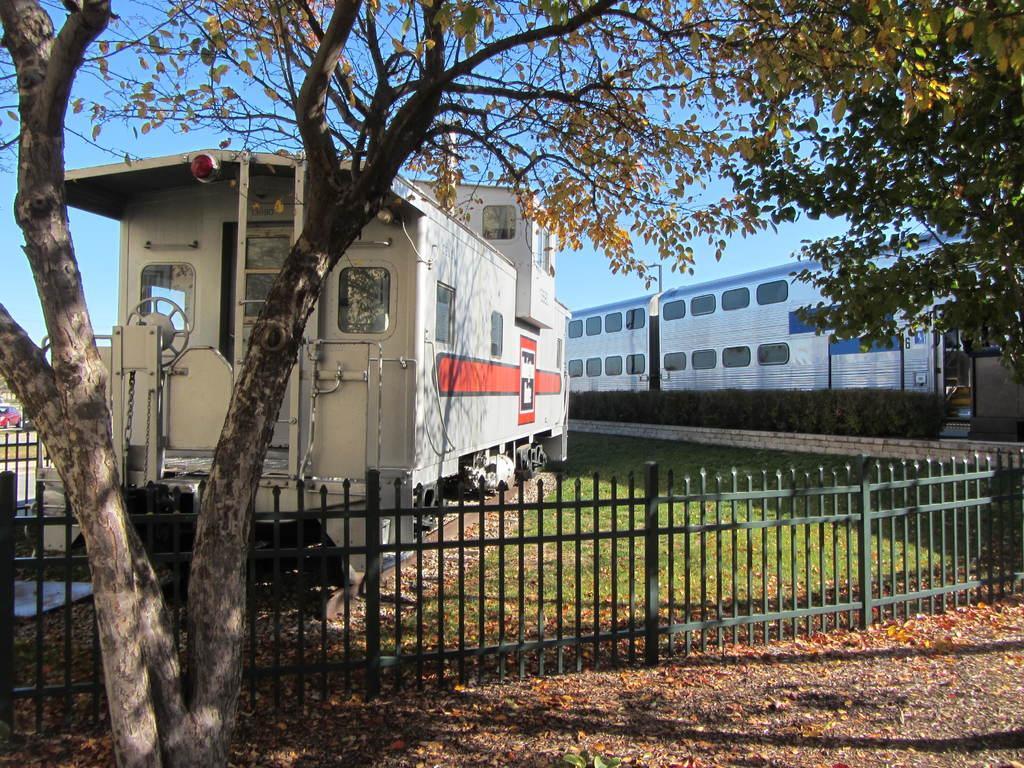How would you summarize this image in a sentence or two? In this picture we can see the trains, trees, grass, bushes, fence, railway track. On the left side of the image we can see a car, road. At the bottom of the image we can see the dry leaves. At the top of the image we can see the sky. 